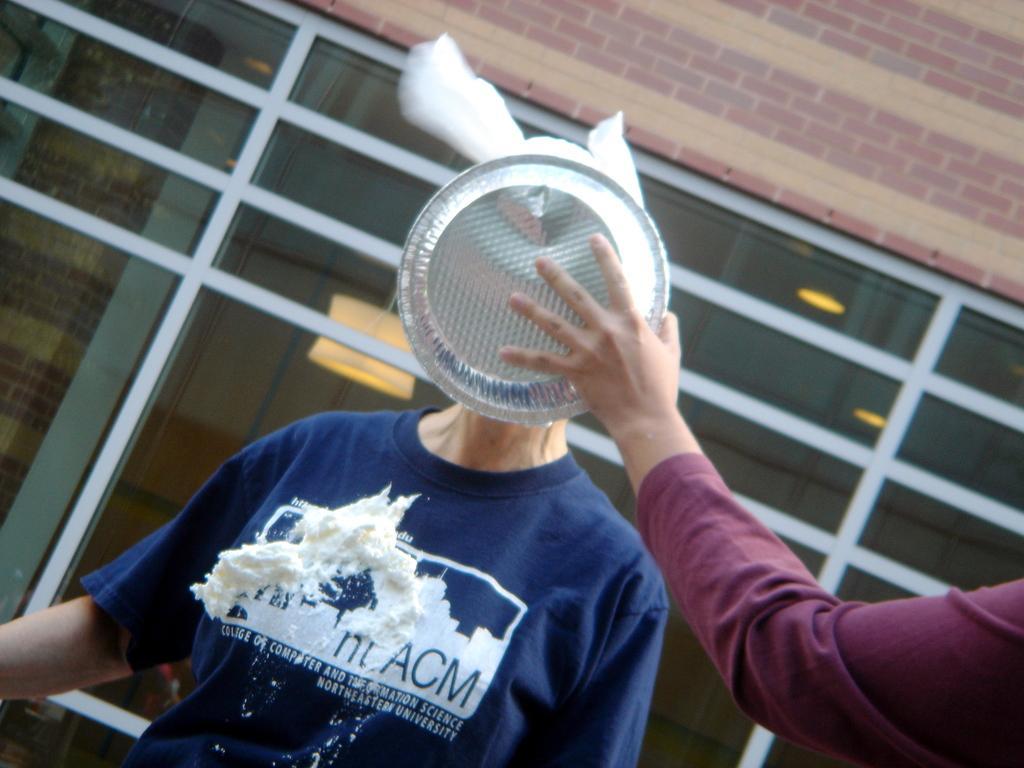Could you give a brief overview of what you see in this image? In this image we can see a person. Also we can see a person hand with a plate. In the background there is wall. 